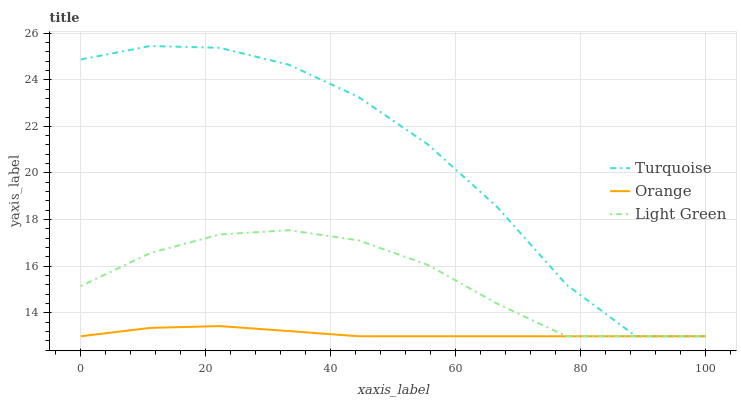Does Orange have the minimum area under the curve?
Answer yes or no. Yes. Does Turquoise have the maximum area under the curve?
Answer yes or no. Yes. Does Light Green have the minimum area under the curve?
Answer yes or no. No. Does Light Green have the maximum area under the curve?
Answer yes or no. No. Is Orange the smoothest?
Answer yes or no. Yes. Is Turquoise the roughest?
Answer yes or no. Yes. Is Light Green the smoothest?
Answer yes or no. No. Is Light Green the roughest?
Answer yes or no. No. Does Orange have the lowest value?
Answer yes or no. Yes. Does Turquoise have the highest value?
Answer yes or no. Yes. Does Light Green have the highest value?
Answer yes or no. No. Does Turquoise intersect Orange?
Answer yes or no. Yes. Is Turquoise less than Orange?
Answer yes or no. No. Is Turquoise greater than Orange?
Answer yes or no. No. 